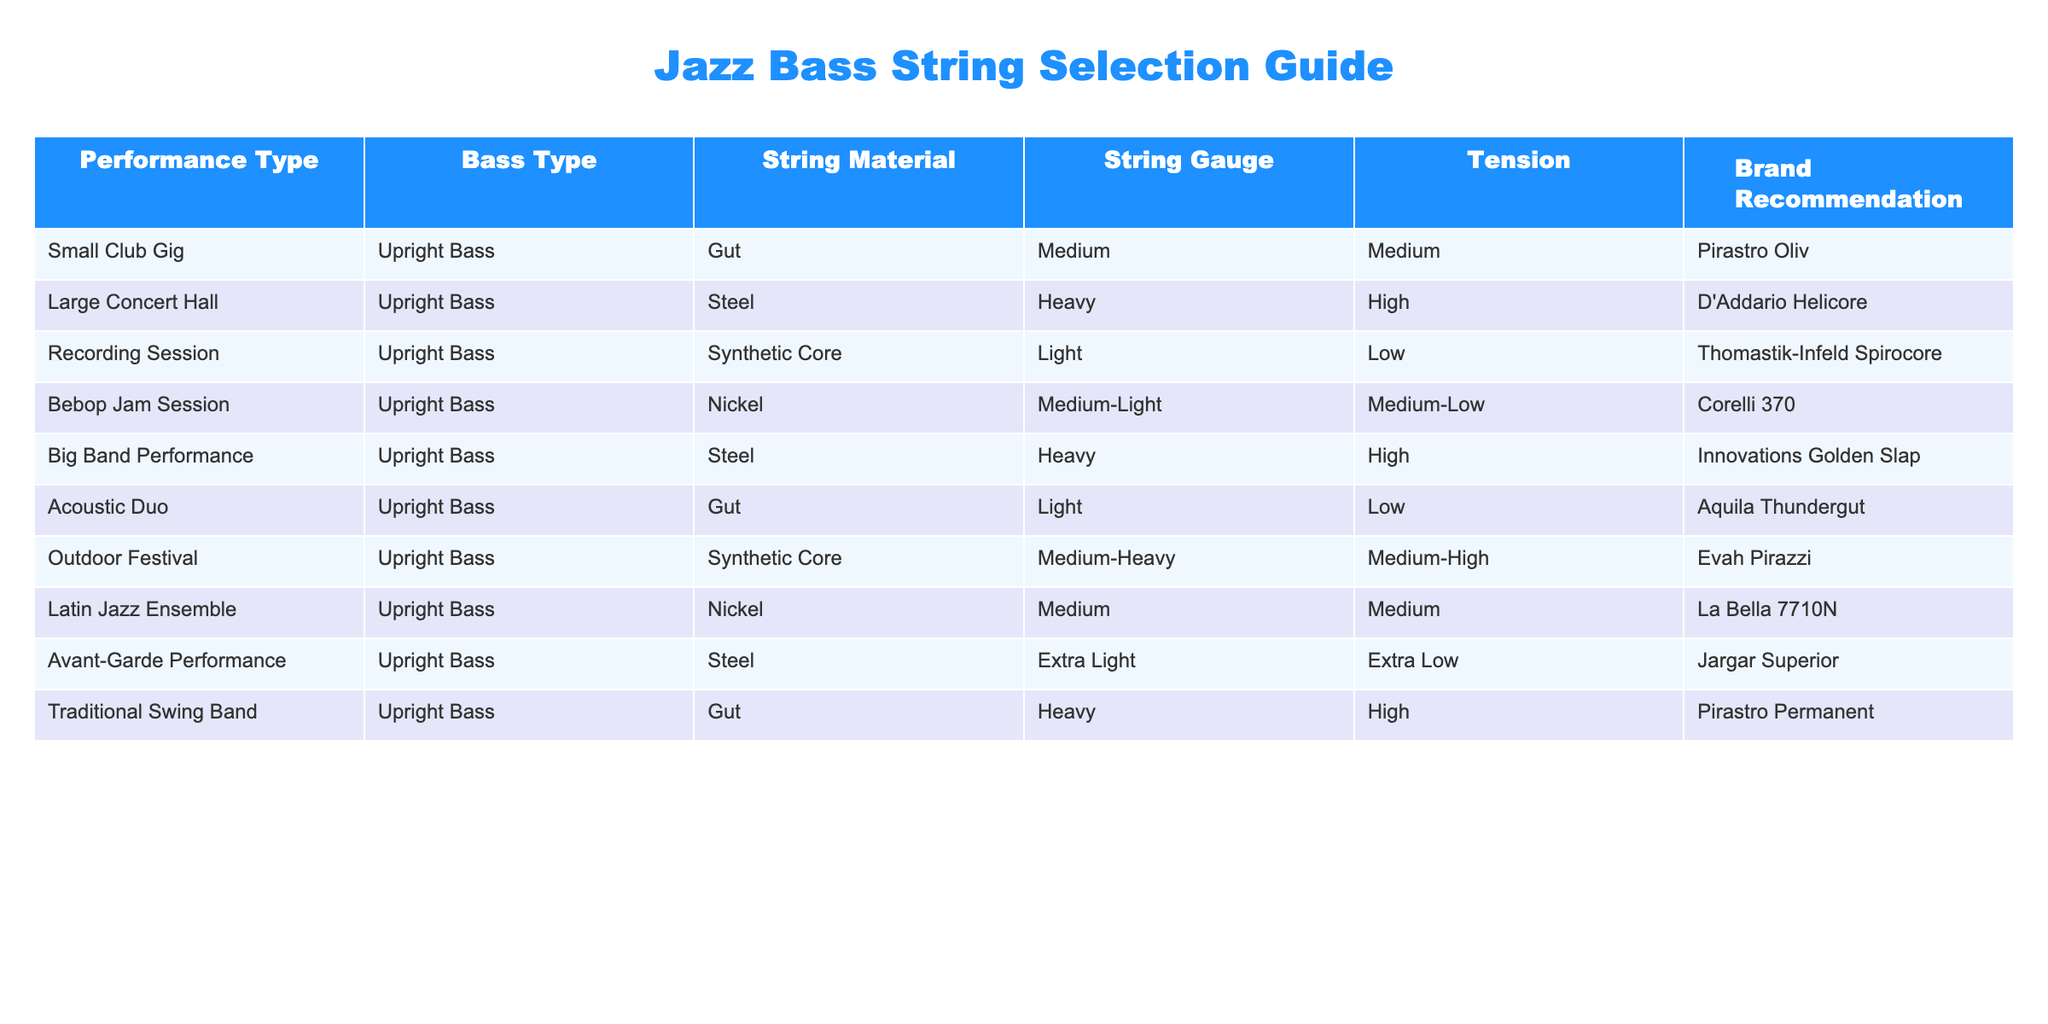What type of strings are recommended for a Big Band Performance? The table lists the recommended strings for each performance type. For Big Band Performance, the string type indicated is "Steel" and the gauge is "Heavy."
Answer: Steel What is the tension of the strings used in Bebop Jam Session? Referring to the Bebop Jam Session row, the tension is labeled as "Medium-Low."
Answer: Medium-Low Are Gut strings recommended for Recording Sessions? Checking the Recording Session row, the string material is "Synthetic Core," not Gut. Therefore, Gut strings are not recommended for this performance type.
Answer: No What is the total number of different string materials mentioned in the table? The table mentions the following string materials: Gut, Steel, Synthetic Core, Nickel. To count them, we list them: 1. Gut 2. Steel 3. Synthetic Core 4. Nickel. This gives us a total of 4 different string materials.
Answer: 4 What is the tension difference between strings used in Large Concert Hall and Traditional Swing Band performances? For the Large Concert Hall, the tension is "High," and for the Traditional Swing Band, the tension is also "High." Therefore, the difference in tension is zero.
Answer: 0 Which performance type has the lightest string gauge among the recommendations? By examining all rows for the "String Gauge" column, we find the lightest is "Extra Light," which corresponds to the Avant-Garde Performance. Thus, this performance type has the lightest gauge.
Answer: Avant-Garde Performance Is Nickel the string material used in any recording sessions? The table does not list Nickel as the string material for a Recording Session; instead, it specifies "Synthetic Core." So, Nickel is not used in this context.
Answer: No How many performance types recommend using Heavy gauge strings? From the table, we check for "Heavy" gauge across the rows and find it recommended in the Large Concert Hall, Big Band Performance, and Traditional Swing Band rows. This sums up to three performance types.
Answer: 3 What brands are recommended for performing with Gut strings? Referring to the rows for Gut strings, we find two recommendations: "Pirastro Oliv" for Small Club Gig and "Pirastro Permanent" for Traditional Swing Band. Both brands are specified for these performances using Gut strings.
Answer: Pirastro Oliv, Pirastro Permanent 